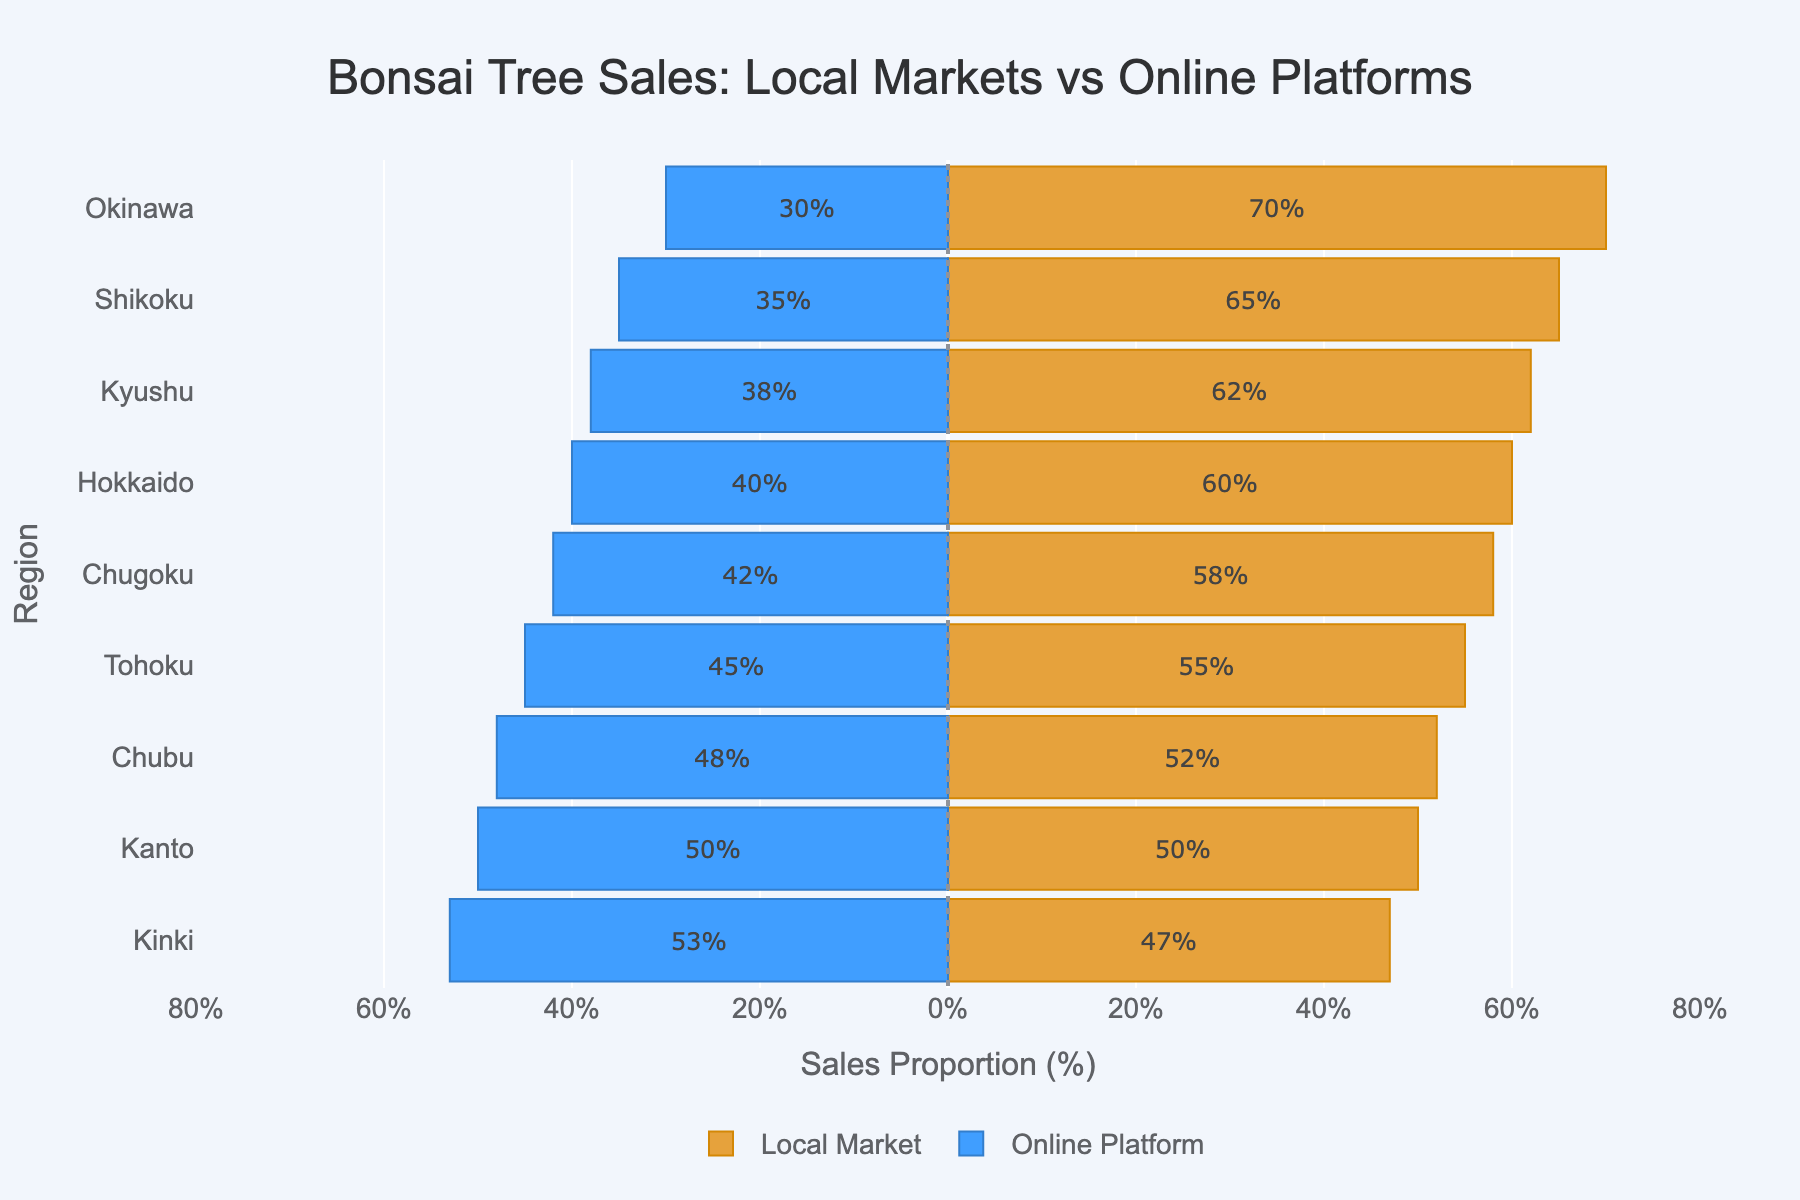Which region has the highest proportion of bonsai tree sales through local markets? To find the region with the highest proportion of bonsai tree sales through local markets, look at the bar representing the local market sales. The longest bar indicates the highest proportion.
Answer: Okinawa Which region has a balanced bonsai tree sales proportion between local markets and online platforms? To identify the region with a balanced sales distribution, locate the region where the bars for local markets and online platforms are equal in length.
Answer: Kanto Which region has the greatest difference in bonsai tree sales between local markets and online platforms? To find the region with the greatest sales difference, check the data values and look for the highest absolute value of the local market minus online platform sales.
Answer: Okinawa For which region is the online platform sales proportion greater than local market sales proportion? Regions where the blue bar (online platform) extends further to the left (negative) side than the orange bar (local market) extends to the right indicate a higher online platform sales proportion.
Answer: Kinki What's the combined percentage of bonsai tree sales through local markets and online platforms in Hokkaido? Sum the proportions of local market and online platform sales for Hokkaido: 60 + 40.
Answer: 100% How much greater is the proportion of local market sales compared to online platform sales in Kyushu? Subtract the percentage of online platform sales from local market sales in Kyushu: 62 - 38.
Answer: 24% Which region shows the least difference between local market and online platform bonsai tree sales? The least difference is identified where the lengths of the bars (local market and online platform) are closest in size.
Answer: Kanto Which region has the same proportion for local market and online platform bonsai tree sales? Identify the region where the local market bar length equals the online platform bar length.
Answer: Kanto What is the percentage of online platform sales in Tohoku? Check the length of the Tohoku bar for online platform sales.
Answer: 45% In which region are local market sales closest to half of the total bonsai tree sales? Local market sales will be closest to half when the orange bar approximates 50% of the total (or near 50% in value).
Answer: Kanto 